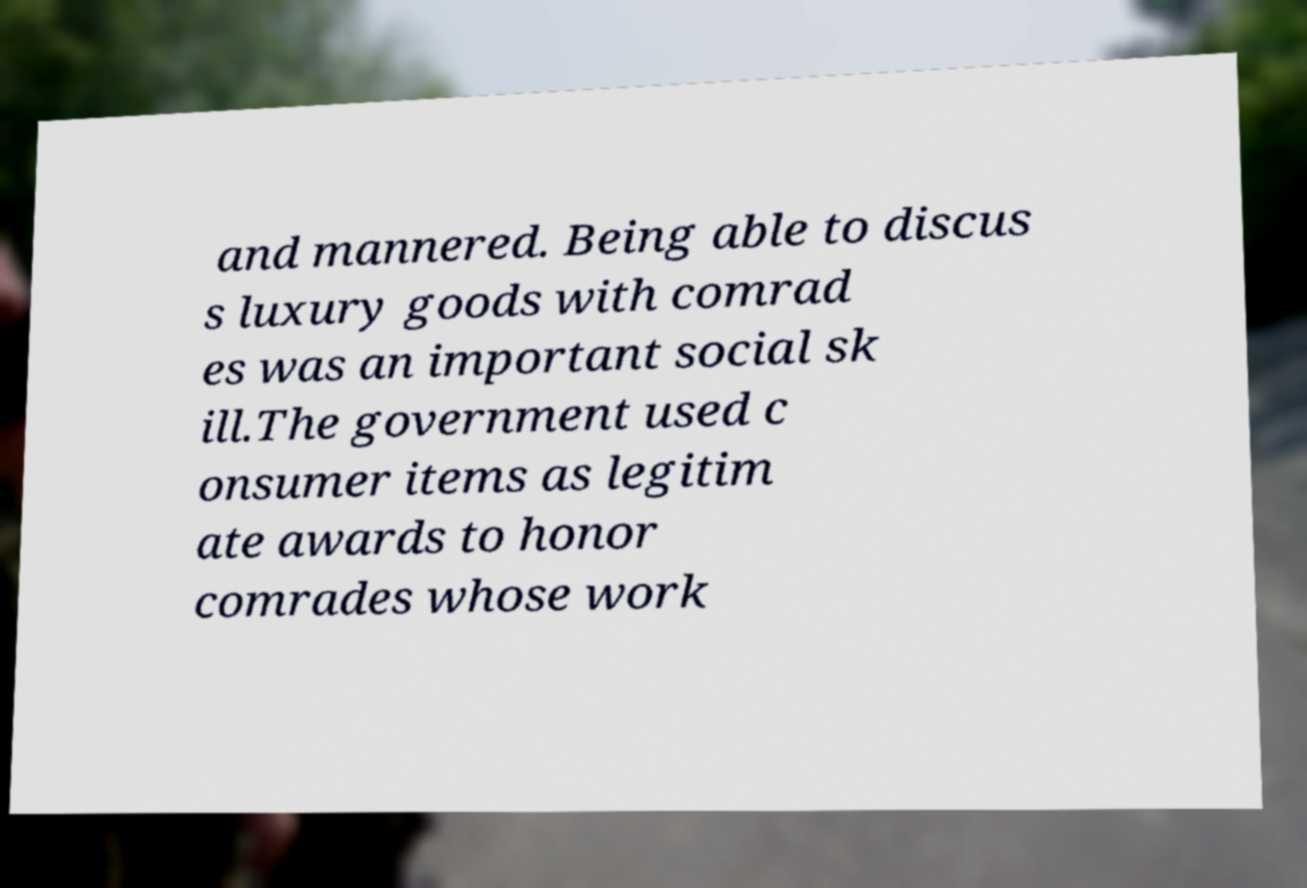What messages or text are displayed in this image? I need them in a readable, typed format. and mannered. Being able to discus s luxury goods with comrad es was an important social sk ill.The government used c onsumer items as legitim ate awards to honor comrades whose work 